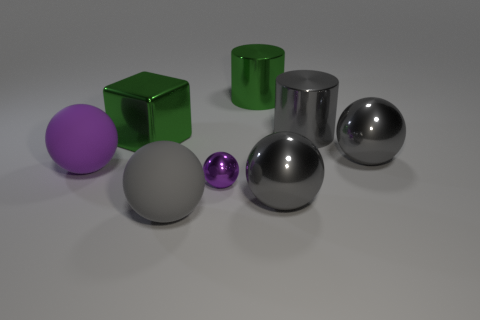What shape is the purple object that is right of the purple rubber sphere?
Give a very brief answer. Sphere. Is there a cylinder of the same size as the green metallic block?
Offer a terse response. Yes. There is a green cylinder that is the same size as the metallic block; what is its material?
Provide a short and direct response. Metal. There is a purple object that is left of the block; what size is it?
Your answer should be compact. Large. How big is the gray rubber sphere?
Provide a short and direct response. Large. There is a green cylinder; does it have the same size as the gray object behind the large green cube?
Make the answer very short. Yes. There is a big shiny ball left of the sphere behind the big purple thing; what is its color?
Offer a terse response. Gray. Is the number of purple matte balls that are behind the big purple rubber thing the same as the number of big green shiny things that are right of the big shiny cube?
Make the answer very short. No. Is the material of the gray object on the left side of the tiny sphere the same as the tiny object?
Your answer should be very brief. No. The ball that is behind the purple metallic thing and to the left of the tiny purple thing is what color?
Provide a succinct answer. Purple. 